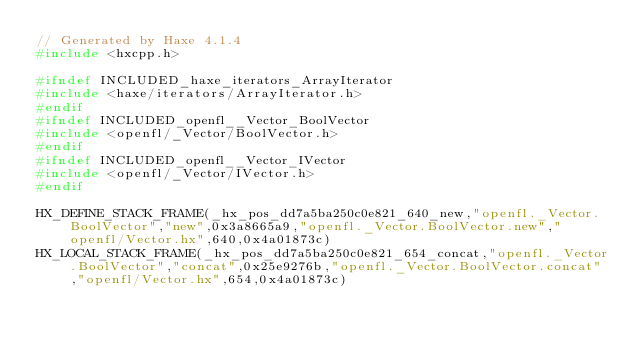Convert code to text. <code><loc_0><loc_0><loc_500><loc_500><_C++_>// Generated by Haxe 4.1.4
#include <hxcpp.h>

#ifndef INCLUDED_haxe_iterators_ArrayIterator
#include <haxe/iterators/ArrayIterator.h>
#endif
#ifndef INCLUDED_openfl__Vector_BoolVector
#include <openfl/_Vector/BoolVector.h>
#endif
#ifndef INCLUDED_openfl__Vector_IVector
#include <openfl/_Vector/IVector.h>
#endif

HX_DEFINE_STACK_FRAME(_hx_pos_dd7a5ba250c0e821_640_new,"openfl._Vector.BoolVector","new",0x3a8665a9,"openfl._Vector.BoolVector.new","openfl/Vector.hx",640,0x4a01873c)
HX_LOCAL_STACK_FRAME(_hx_pos_dd7a5ba250c0e821_654_concat,"openfl._Vector.BoolVector","concat",0x25e9276b,"openfl._Vector.BoolVector.concat","openfl/Vector.hx",654,0x4a01873c)</code> 